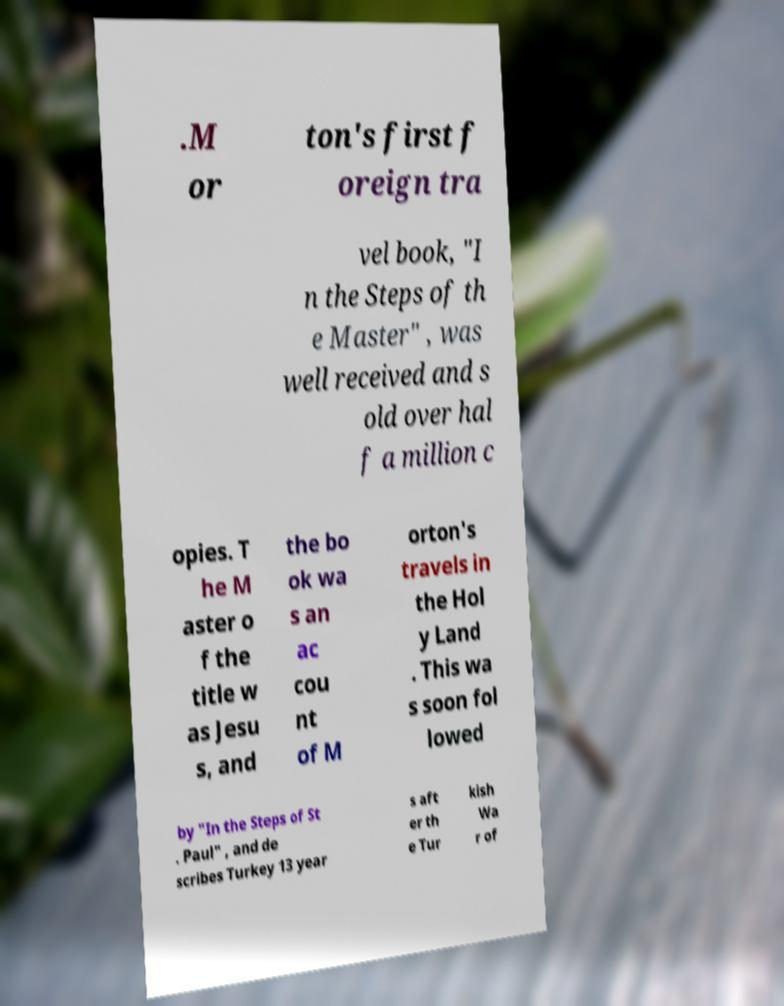Can you accurately transcribe the text from the provided image for me? .M or ton's first f oreign tra vel book, "I n the Steps of th e Master" , was well received and s old over hal f a million c opies. T he M aster o f the title w as Jesu s, and the bo ok wa s an ac cou nt of M orton's travels in the Hol y Land . This wa s soon fol lowed by "In the Steps of St . Paul" , and de scribes Turkey 13 year s aft er th e Tur kish Wa r of 